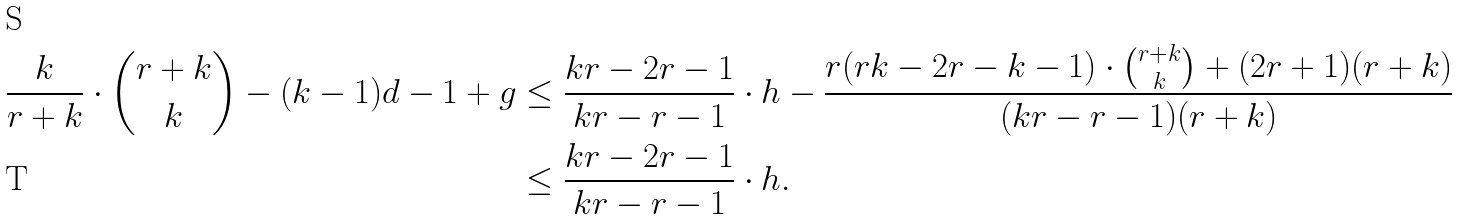Convert formula to latex. <formula><loc_0><loc_0><loc_500><loc_500>\frac { k } { r + k } \cdot \binom { r + k } { k } - ( k - 1 ) d - 1 + g & \leq \frac { k r - 2 r - 1 } { k r - r - 1 } \cdot h - \frac { r ( r k - 2 r - k - 1 ) \cdot \binom { r + k } { k } + ( 2 r + 1 ) ( r + k ) } { ( k r - r - 1 ) ( r + k ) } \\ & \leq \frac { k r - 2 r - 1 } { k r - r - 1 } \cdot h .</formula> 